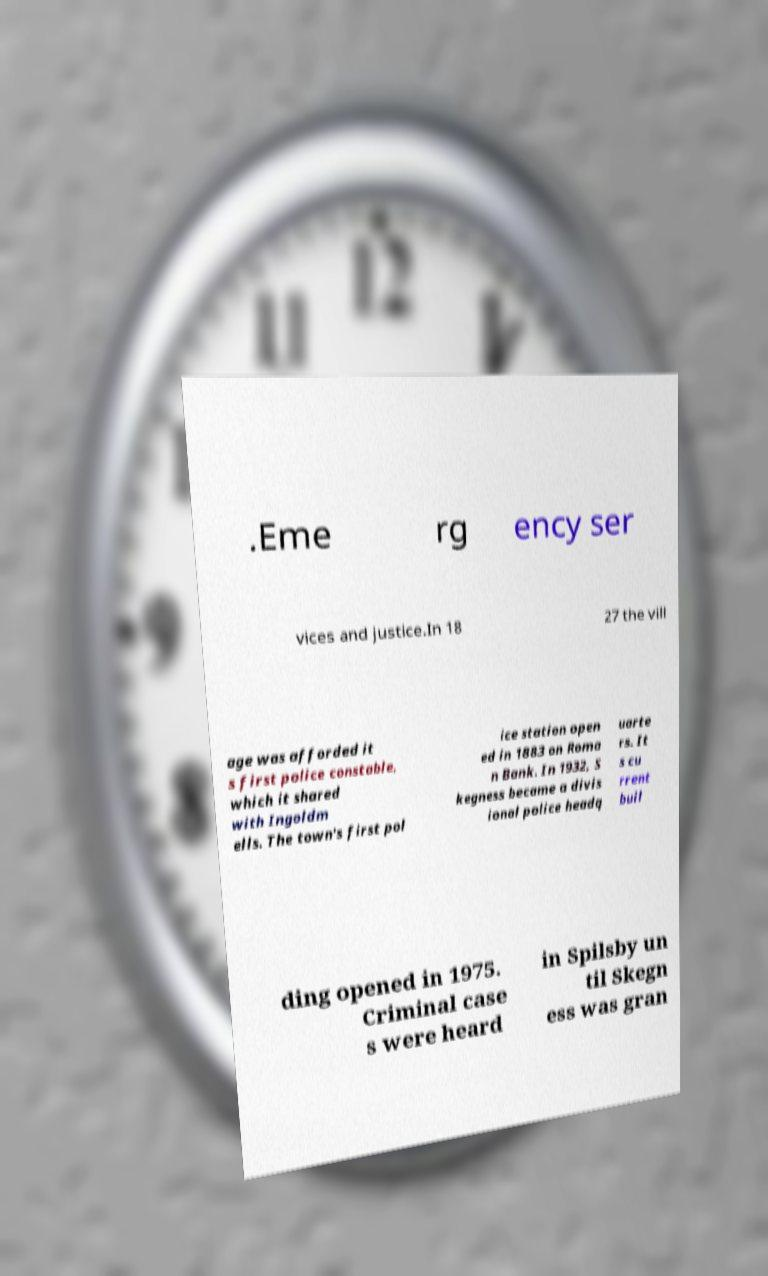I need the written content from this picture converted into text. Can you do that? .Eme rg ency ser vices and justice.In 18 27 the vill age was afforded it s first police constable, which it shared with Ingoldm ells. The town's first pol ice station open ed in 1883 on Roma n Bank. In 1932, S kegness became a divis ional police headq uarte rs. It s cu rrent buil ding opened in 1975. Criminal case s were heard in Spilsby un til Skegn ess was gran 